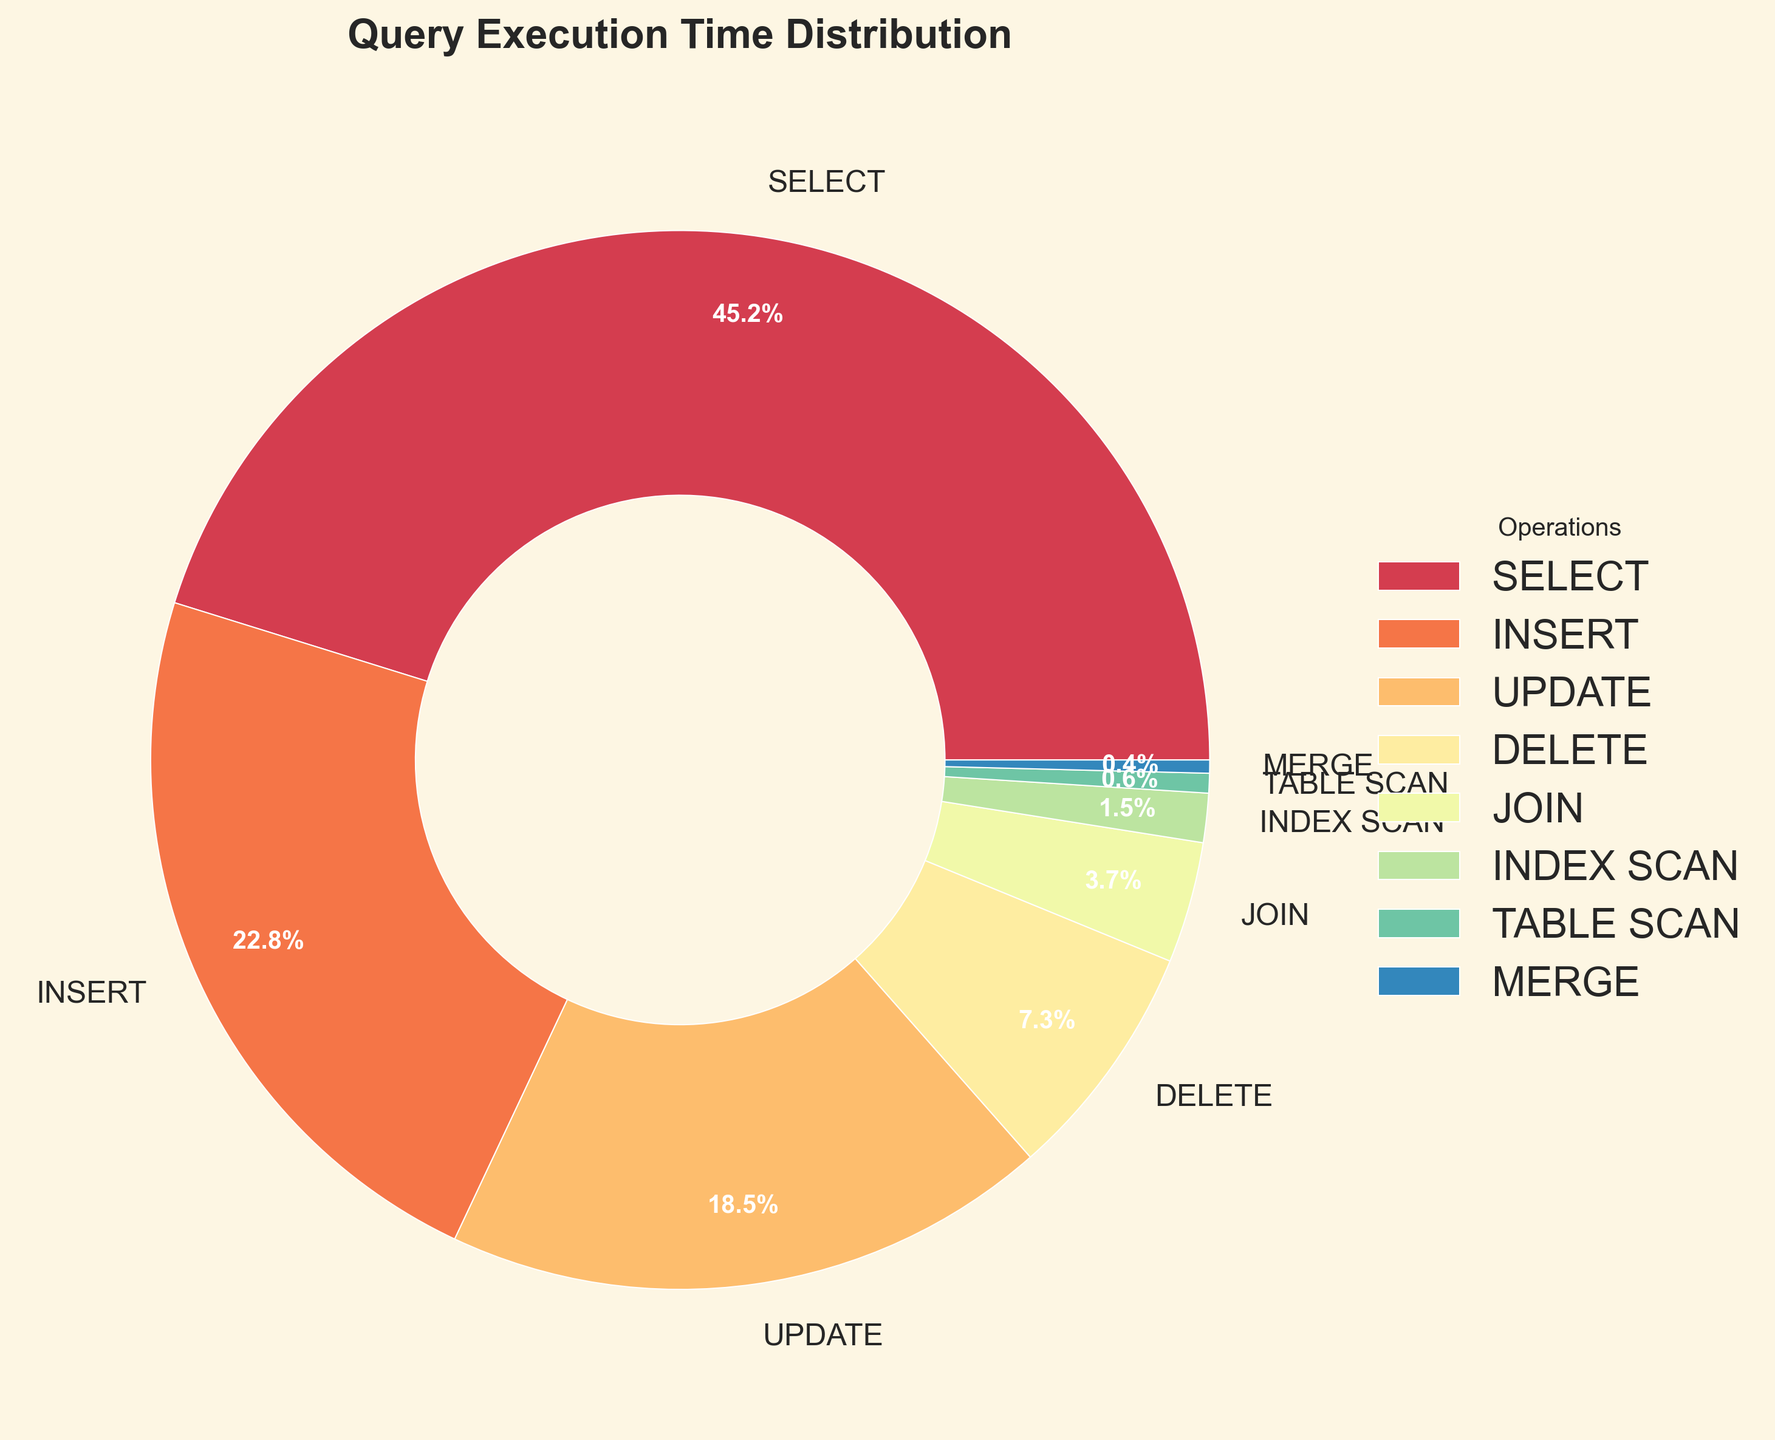Which operation has the largest percentage of query execution time? The SELECT operation has the largest percentage. It is 45.2% which is the highest compared to other operations.
Answer: SELECT What is the combined percentage of INSERT and UPDATE operations? The percentage for INSERT is 22.8%, and UPDATE is 18.5%. Summing these up: 22.8 + 18.5 = 41.3%.
Answer: 41.3% What is the percentage difference between DELETE and TABLE SCAN operations? The percentage for DELETE is 7.3% and TABLE SCAN is 0.6%. The difference is 7.3 - 0.6 = 6.7%.
Answer: 6.7% Does the INSERT operation take more or less than double the time of the DELETE operation? The INSERT operation takes 22.8% of the time, while DELETE takes 7.3%. Double of 7.3 is 14.6. Since 22.8% is greater than 14.6%, INSERT takes more than double the time of DELETE.
Answer: More Which operation has the smallest contribution to query execution time? MERGE has the smallest contribution at 0.4%.
Answer: MERGE Is the total percentage of JOIN, INDEX SCAN, TABLE SCAN, and MERGE greater than that of the DELETE operation? Summing the percentages for JOIN (3.7%), INDEX SCAN (1.5%), TABLE SCAN (0.6%), and MERGE (0.4%) gives: 3.7 + 1.5 + 0.6 + 0.4 = 6.2%. Since DELETE is 7.3%, 6.2% is less than 7.3%.
Answer: No Which operations take up more than 20% of query execution time? The SELECT operation at 45.2% and the INSERT operation at 22.8% both take up more than 20% of the execution time.
Answer: SELECT, INSERT By what percentage does the UPDATE operation exceed the JOIN operation? The UPDATE operation is 18.5% and the JOIN operation is 3.7%. The difference is 18.5 - 3.7 = 14.8%.
Answer: 14.8% Are there more operations that have a percentage below or above 10%? The operations with a percentage below 10% are DELETE (7.3%), JOIN (3.7%), INDEX SCAN (1.5%), TABLE SCAN (0.6%), and MERGE (0.4%), making a total of 5. The operations above 10% are SELECT (45.2%), INSERT (22.8%), and UPDATE (18.5%), totaling 3. Therefore, there are more operations below 10%.
Answer: Below What fraction of the total is contributed by operations other than SELECT? The percentage contributed by SELECT is 45.2%. Therefore, the rest is 100 - 45.2 = 54.8%. The fraction is 54.8/100 = 0.548.
Answer: 0.548 